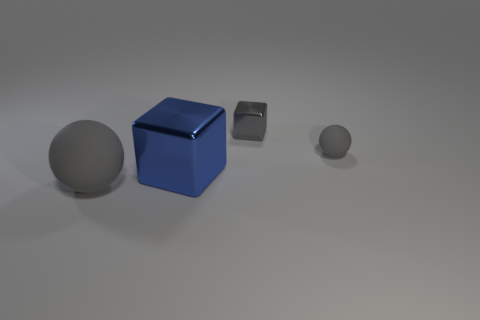Subtract all blue blocks. How many blocks are left? 1 Add 2 green cylinders. How many objects exist? 6 Subtract all large gray matte things. Subtract all large gray blocks. How many objects are left? 3 Add 4 matte objects. How many matte objects are left? 6 Add 1 large rubber spheres. How many large rubber spheres exist? 2 Subtract 2 gray spheres. How many objects are left? 2 Subtract 1 balls. How many balls are left? 1 Subtract all brown balls. Subtract all green cylinders. How many balls are left? 2 Subtract all red cylinders. How many gray cubes are left? 1 